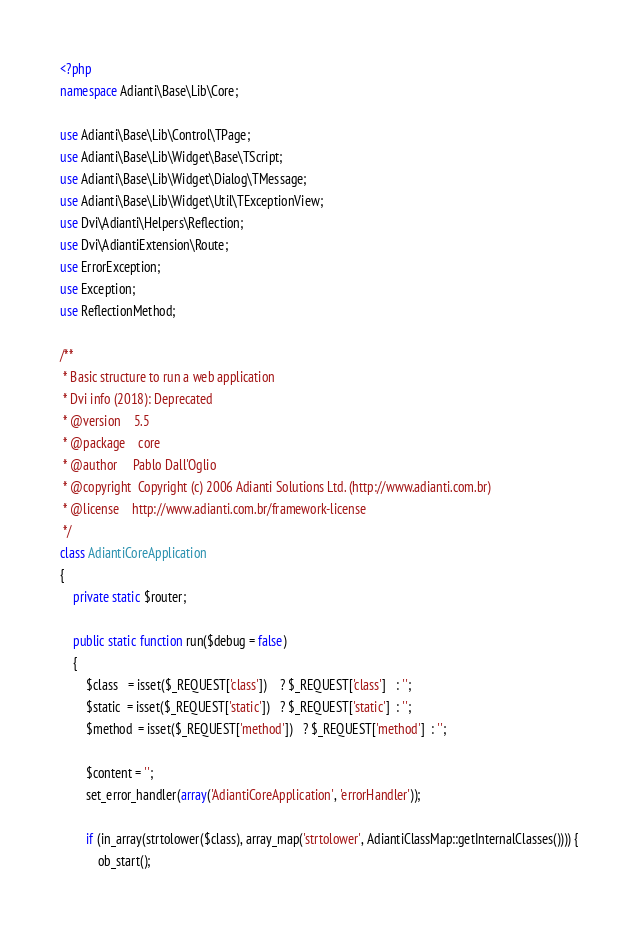Convert code to text. <code><loc_0><loc_0><loc_500><loc_500><_PHP_><?php
namespace Adianti\Base\Lib\Core;

use Adianti\Base\Lib\Control\TPage;
use Adianti\Base\Lib\Widget\Base\TScript;
use Adianti\Base\Lib\Widget\Dialog\TMessage;
use Adianti\Base\Lib\Widget\Util\TExceptionView;
use Dvi\Adianti\Helpers\Reflection;
use Dvi\AdiantiExtension\Route;
use ErrorException;
use Exception;
use ReflectionMethod;

/**
 * Basic structure to run a web application
 * Dvi info (2018): Deprecated
 * @version    5.5
 * @package    core
 * @author     Pablo Dall'Oglio
 * @copyright  Copyright (c) 2006 Adianti Solutions Ltd. (http://www.adianti.com.br)
 * @license    http://www.adianti.com.br/framework-license
 */
class AdiantiCoreApplication
{
    private static $router;

    public static function run($debug = false)
    {
        $class   = isset($_REQUEST['class'])    ? $_REQUEST['class']   : '';
        $static  = isset($_REQUEST['static'])   ? $_REQUEST['static']  : '';
        $method  = isset($_REQUEST['method'])   ? $_REQUEST['method']  : '';

        $content = '';
        set_error_handler(array('AdiantiCoreApplication', 'errorHandler'));

        if (in_array(strtolower($class), array_map('strtolower', AdiantiClassMap::getInternalClasses()))) {
            ob_start();</code> 